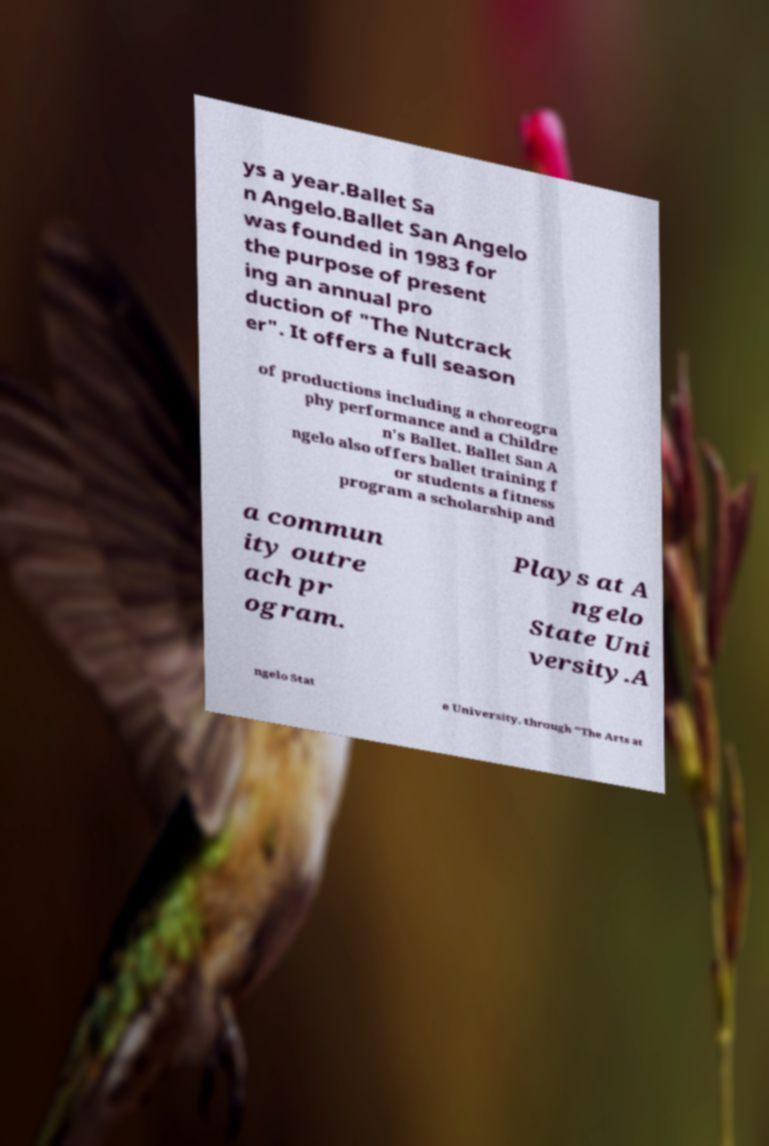I need the written content from this picture converted into text. Can you do that? ys a year.Ballet Sa n Angelo.Ballet San Angelo was founded in 1983 for the purpose of present ing an annual pro duction of "The Nutcrack er". It offers a full season of productions including a choreogra phy performance and a Childre n's Ballet. Ballet San A ngelo also offers ballet training f or students a fitness program a scholarship and a commun ity outre ach pr ogram. Plays at A ngelo State Uni versity.A ngelo Stat e University, through "The Arts at 